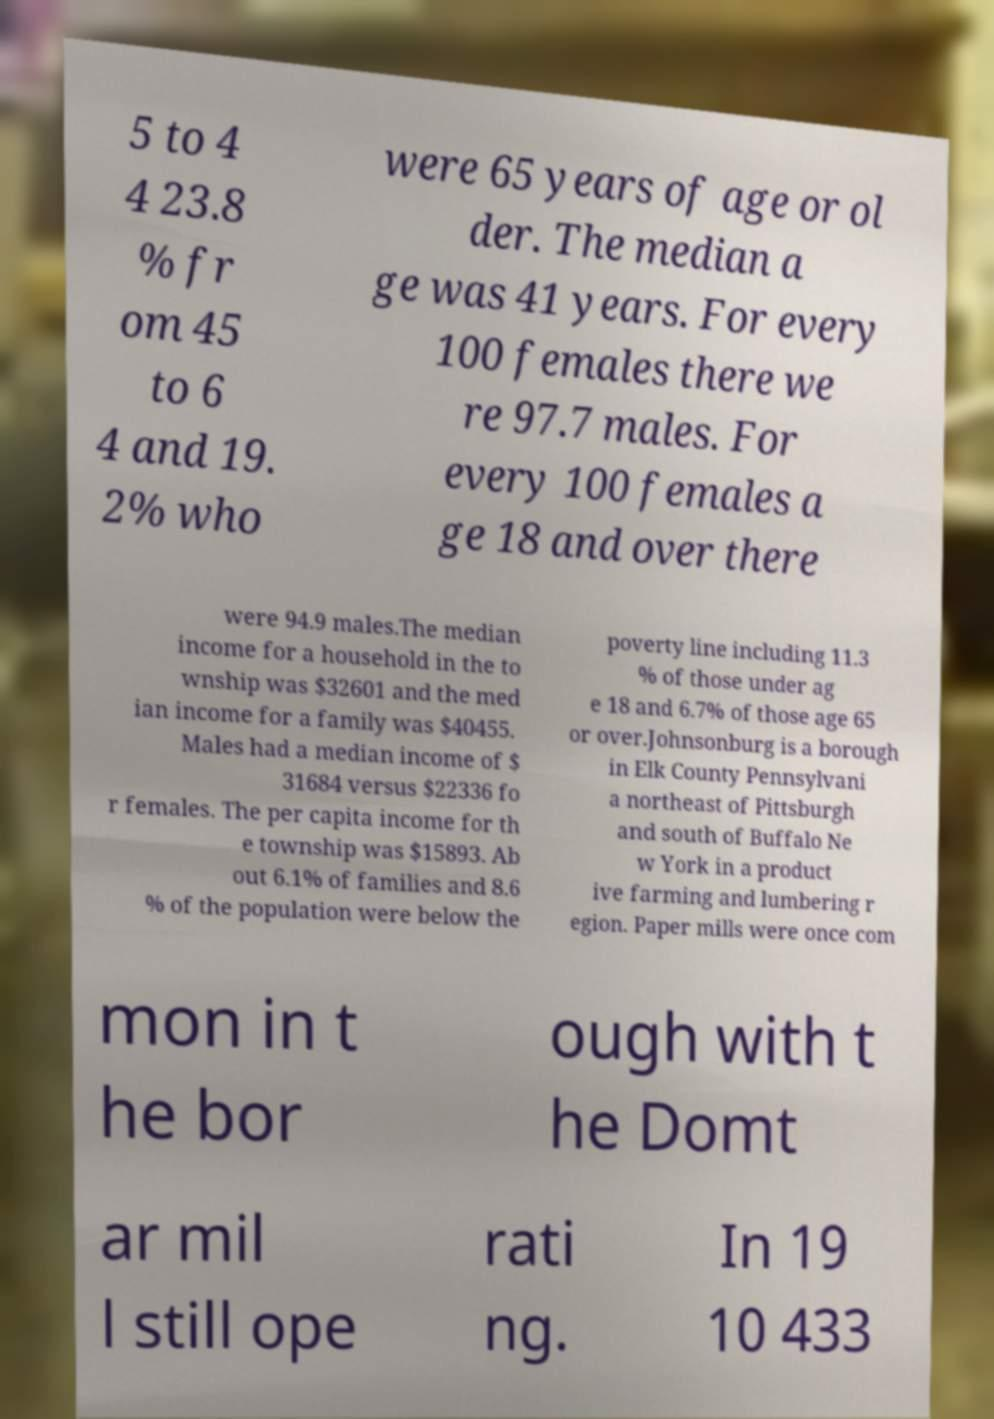Could you extract and type out the text from this image? 5 to 4 4 23.8 % fr om 45 to 6 4 and 19. 2% who were 65 years of age or ol der. The median a ge was 41 years. For every 100 females there we re 97.7 males. For every 100 females a ge 18 and over there were 94.9 males.The median income for a household in the to wnship was $32601 and the med ian income for a family was $40455. Males had a median income of $ 31684 versus $22336 fo r females. The per capita income for th e township was $15893. Ab out 6.1% of families and 8.6 % of the population were below the poverty line including 11.3 % of those under ag e 18 and 6.7% of those age 65 or over.Johnsonburg is a borough in Elk County Pennsylvani a northeast of Pittsburgh and south of Buffalo Ne w York in a product ive farming and lumbering r egion. Paper mills were once com mon in t he bor ough with t he Domt ar mil l still ope rati ng. In 19 10 433 